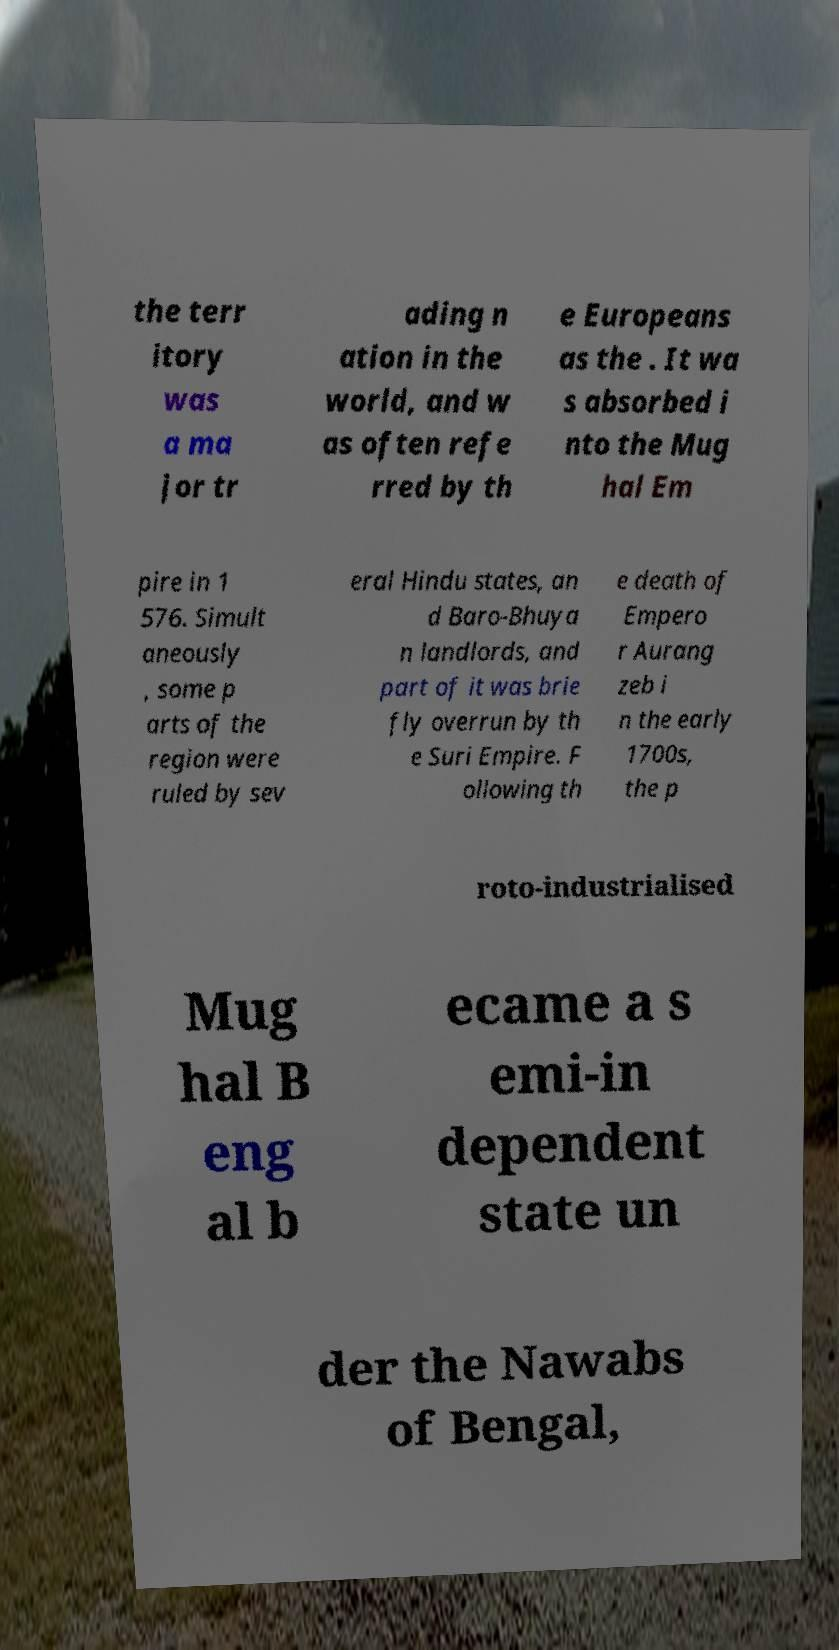For documentation purposes, I need the text within this image transcribed. Could you provide that? the terr itory was a ma jor tr ading n ation in the world, and w as often refe rred by th e Europeans as the . It wa s absorbed i nto the Mug hal Em pire in 1 576. Simult aneously , some p arts of the region were ruled by sev eral Hindu states, an d Baro-Bhuya n landlords, and part of it was brie fly overrun by th e Suri Empire. F ollowing th e death of Empero r Aurang zeb i n the early 1700s, the p roto-industrialised Mug hal B eng al b ecame a s emi-in dependent state un der the Nawabs of Bengal, 